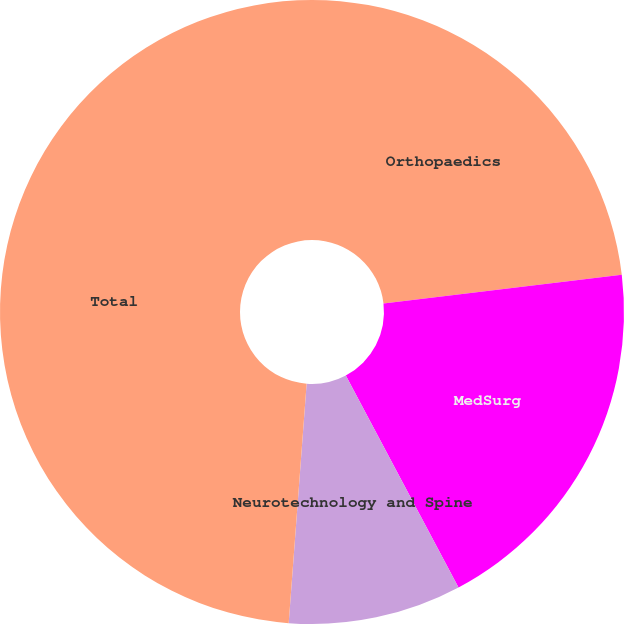<chart> <loc_0><loc_0><loc_500><loc_500><pie_chart><fcel>Orthopaedics<fcel>MedSurg<fcel>Neurotechnology and Spine<fcel>Total<nl><fcel>23.1%<fcel>19.12%<fcel>8.97%<fcel>48.81%<nl></chart> 